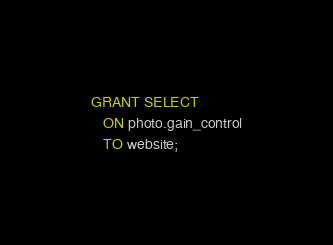<code> <loc_0><loc_0><loc_500><loc_500><_SQL_>GRANT SELECT
   ON photo.gain_control
   TO website;
</code> 